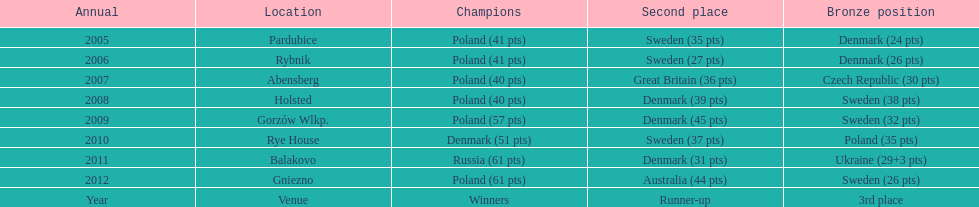When was the first year that poland did not place in the top three positions of the team speedway junior world championship? 2011. 